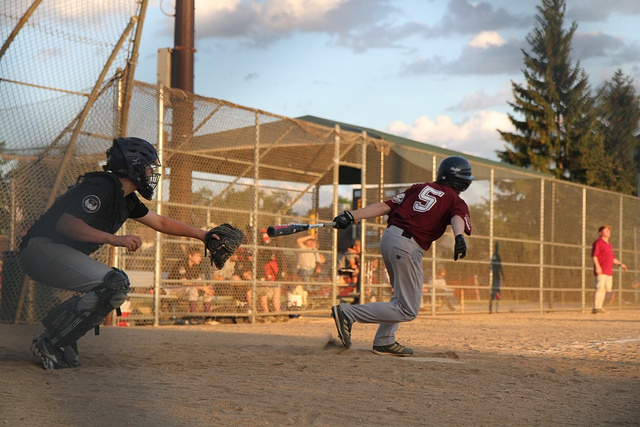Describe the objects in this image and their specific colors. I can see people in darkgray, black, gray, and maroon tones, people in darkgray, black, gray, and maroon tones, people in darkgray, tan, brown, gray, and maroon tones, people in darkgray, tan, and red tones, and people in darkgray, brown, tan, and maroon tones in this image. 